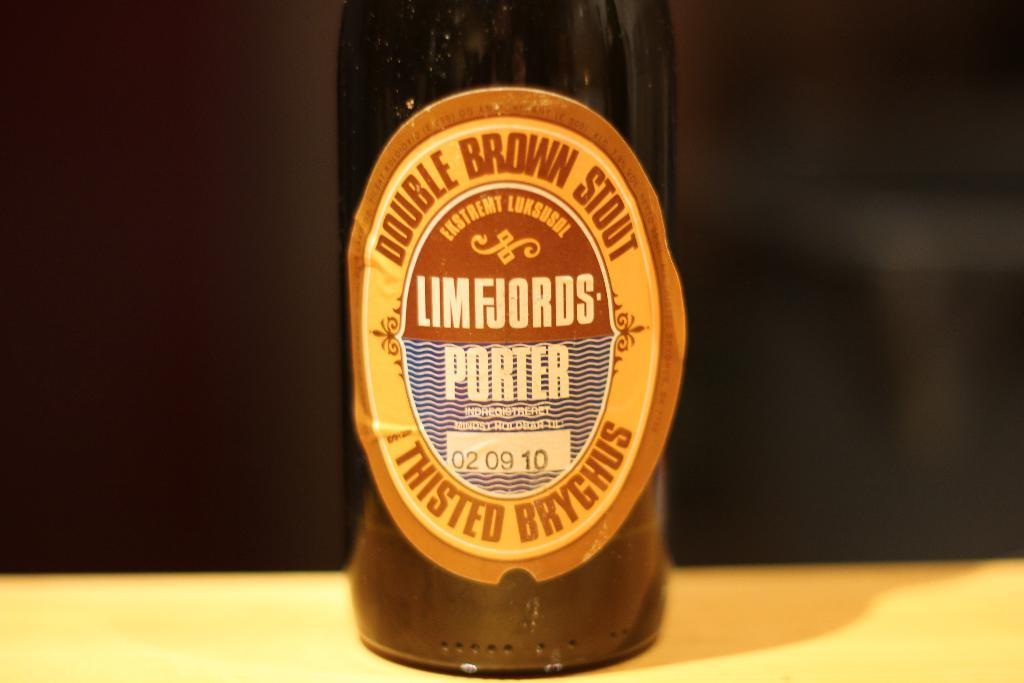<image>
Relay a brief, clear account of the picture shown. A bottle of double brown stout sits on a surface against a black background. 